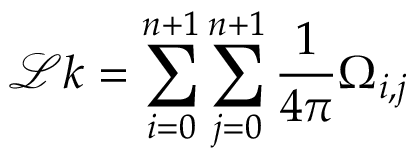<formula> <loc_0><loc_0><loc_500><loc_500>\mathcal { L } k = \sum _ { i = 0 } ^ { n + 1 } \sum _ { j = 0 } ^ { n + 1 } \frac { 1 } { 4 \pi } \Omega _ { i , j }</formula> 